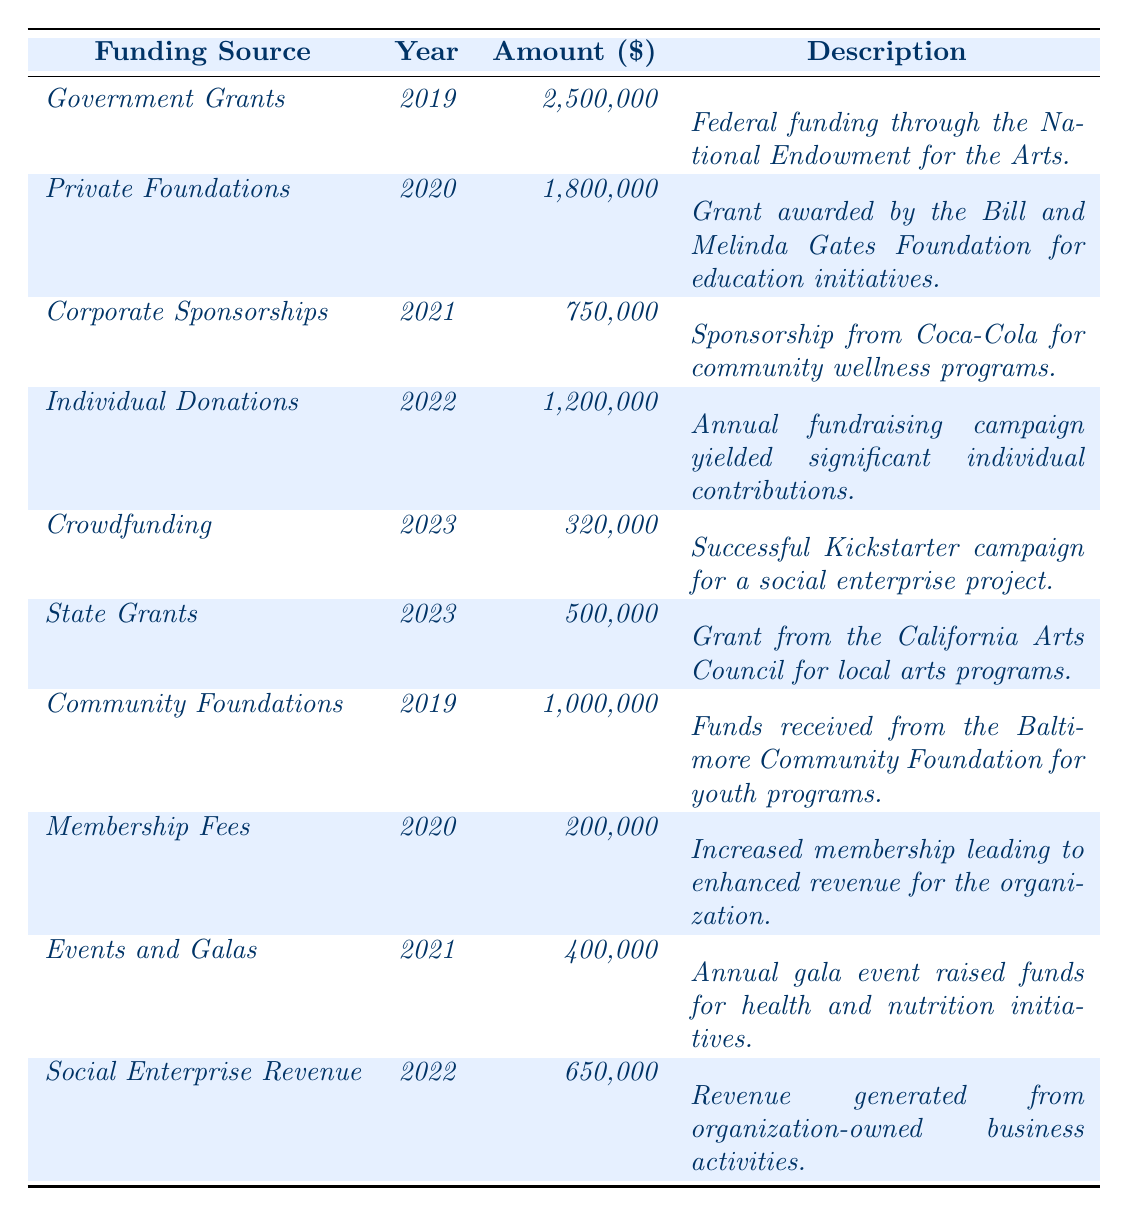What was the total amount received from government grants in 2019? The table states that the amount for government grants in 2019 is $2,500,000. Therefore, the total amount is simply this value.
Answer: $2,500,000 Which funding source received the highest amount in 2020? In 2020, Private Foundations received $1,800,000, and Membership Fees received $200,000. Therefore, Private Foundations had the highest amount that year.
Answer: Private Foundations How much funding did events and galas raise compared to individual donations in 2022? Events and Galas raised $400,000, while Individual Donations raised $1,200,000. The difference is calculated as $1,200,000 - $400,000 = $800,000.
Answer: $800,000 What is the total funding from Community Foundations and Government Grants combined? The amount from Community Foundations is $1,000,000 and from Government Grants is $2,500,000. Their total is $1,000,000 + $2,500,000 = $3,500,000.
Answer: $3,500,000 Did the organization receive more funding from private foundations than corporate sponsorships in 2021? Private Foundations received $1,800,000 in 2020, whereas Corporate Sponsorships received $750,000 in 2021. Since $1,800,000 (private foundations) is greater than $750,000 (corporate sponsorships), the answer is yes.
Answer: Yes How much total funding did the organization receive in 2023? In 2023, the organization received $320,000 from Crowdfunding and $500,000 from State Grants. The total is $320,000 + $500,000 = $820,000.
Answer: $820,000 What funding source accounted for the smallest amount in 2022? In 2022, the smallest amount was from Crowdfunding at $320,000 compared to Social Enterprise Revenue which received $650,000.
Answer: Crowdfunding If we consider all funding sources from 2019 to 2023, which year had the highest total funding amount? To find the highest total per year, we sum the amounts: 2019: $3,500,000, 2020: $2,000,000, 2021: $1,150,000, 2022: $1,850,000, 2023: $820,000. The highest total is in 2019 with $3,500,000.
Answer: 2019 Was there an increase in funding from individual donations from 2021 to 2022? Individual Donations in 2021 are not listed; only donations in 2022 show $1,200,000. Since 2021 doesn't have data listed, we cannot establish a comparison.
Answer: No data for 2021 What type of funding had a significant decrease from 2019 to 2023? In 2019, Government Grants received $2,500,000 and in 2023 the total from Crowdfunding and State Grants is $820,000. This shows a decrease, demonstrating less funding from the same sector over time.
Answer: Government Grants 